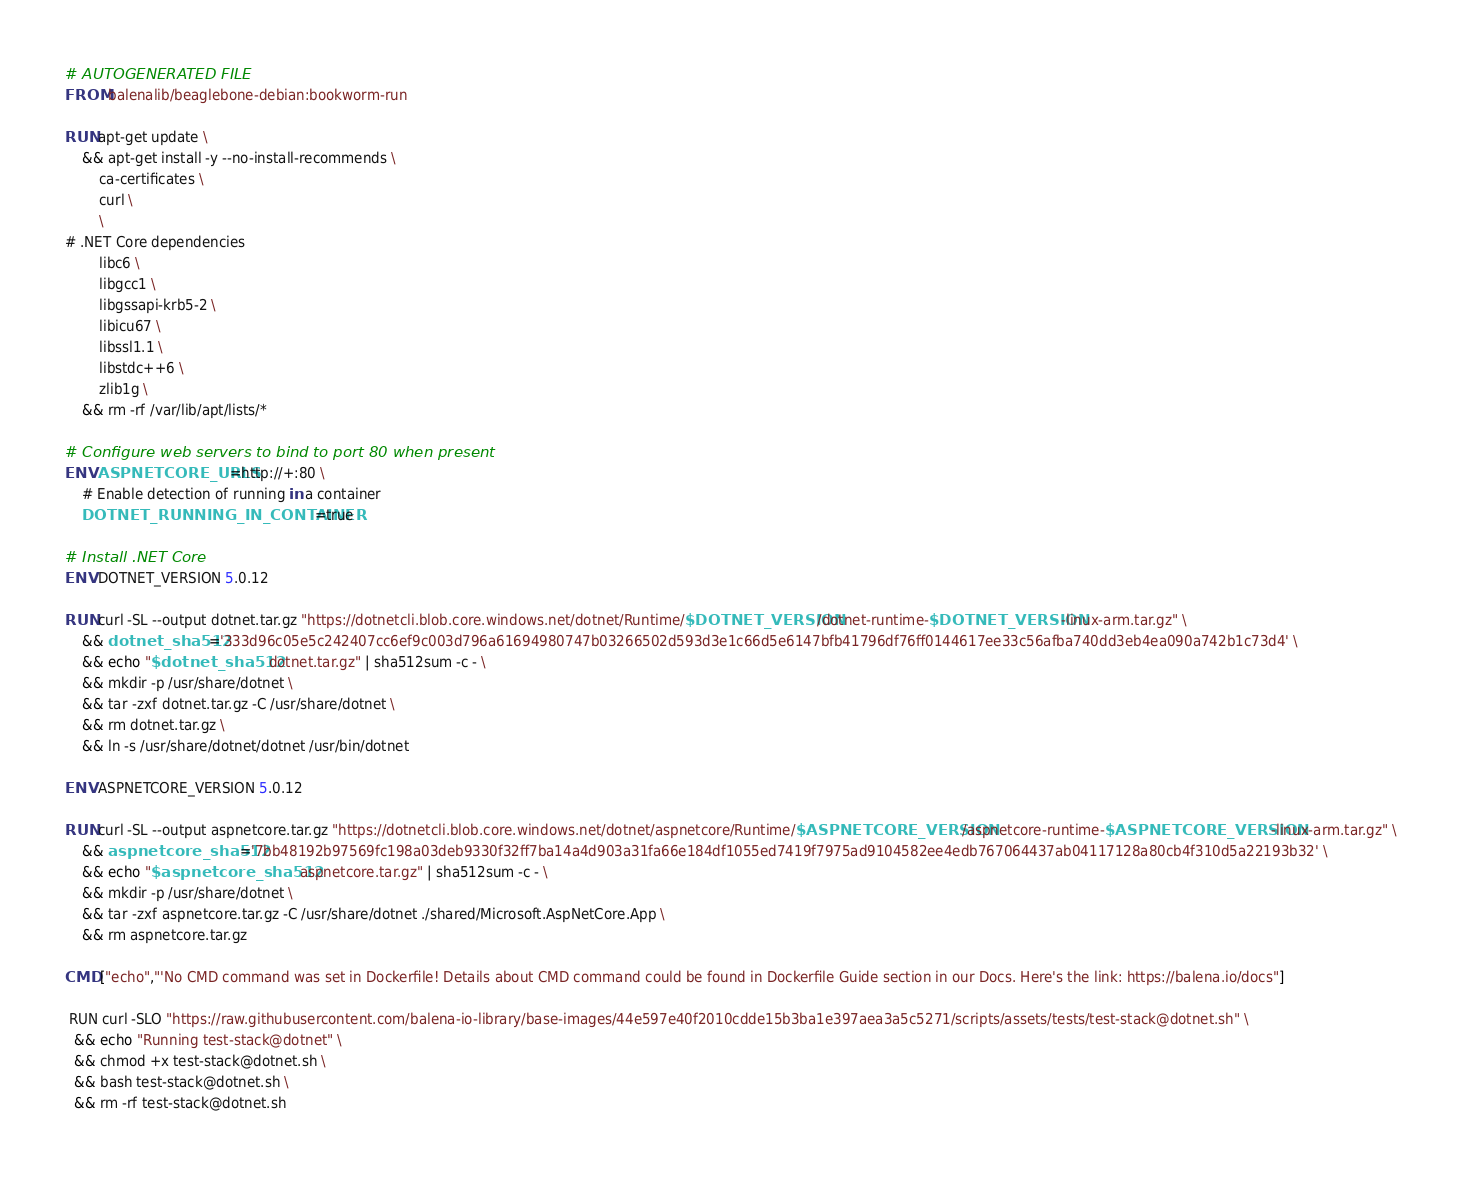<code> <loc_0><loc_0><loc_500><loc_500><_Dockerfile_># AUTOGENERATED FILE
FROM balenalib/beaglebone-debian:bookworm-run

RUN apt-get update \
    && apt-get install -y --no-install-recommends \
        ca-certificates \
        curl \
        \
# .NET Core dependencies
        libc6 \
        libgcc1 \
        libgssapi-krb5-2 \
        libicu67 \
        libssl1.1 \
        libstdc++6 \
        zlib1g \
    && rm -rf /var/lib/apt/lists/*

# Configure web servers to bind to port 80 when present
ENV ASPNETCORE_URLS=http://+:80 \
    # Enable detection of running in a container
    DOTNET_RUNNING_IN_CONTAINER=true

# Install .NET Core
ENV DOTNET_VERSION 5.0.12

RUN curl -SL --output dotnet.tar.gz "https://dotnetcli.blob.core.windows.net/dotnet/Runtime/$DOTNET_VERSION/dotnet-runtime-$DOTNET_VERSION-linux-arm.tar.gz" \
    && dotnet_sha512='333d96c05e5c242407cc6ef9c003d796a61694980747b03266502d593d3e1c66d5e6147bfb41796df76ff0144617ee33c56afba740dd3eb4ea090a742b1c73d4' \
    && echo "$dotnet_sha512  dotnet.tar.gz" | sha512sum -c - \
    && mkdir -p /usr/share/dotnet \
    && tar -zxf dotnet.tar.gz -C /usr/share/dotnet \
    && rm dotnet.tar.gz \
    && ln -s /usr/share/dotnet/dotnet /usr/bin/dotnet

ENV ASPNETCORE_VERSION 5.0.12

RUN curl -SL --output aspnetcore.tar.gz "https://dotnetcli.blob.core.windows.net/dotnet/aspnetcore/Runtime/$ASPNETCORE_VERSION/aspnetcore-runtime-$ASPNETCORE_VERSION-linux-arm.tar.gz" \
    && aspnetcore_sha512='7bb48192b97569fc198a03deb9330f32ff7ba14a4d903a31fa66e184df1055ed7419f7975ad9104582ee4edb767064437ab04117128a80cb4f310d5a22193b32' \
    && echo "$aspnetcore_sha512  aspnetcore.tar.gz" | sha512sum -c - \
    && mkdir -p /usr/share/dotnet \
    && tar -zxf aspnetcore.tar.gz -C /usr/share/dotnet ./shared/Microsoft.AspNetCore.App \
    && rm aspnetcore.tar.gz

CMD ["echo","'No CMD command was set in Dockerfile! Details about CMD command could be found in Dockerfile Guide section in our Docs. Here's the link: https://balena.io/docs"]

 RUN curl -SLO "https://raw.githubusercontent.com/balena-io-library/base-images/44e597e40f2010cdde15b3ba1e397aea3a5c5271/scripts/assets/tests/test-stack@dotnet.sh" \
  && echo "Running test-stack@dotnet" \
  && chmod +x test-stack@dotnet.sh \
  && bash test-stack@dotnet.sh \
  && rm -rf test-stack@dotnet.sh 
</code> 